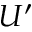<formula> <loc_0><loc_0><loc_500><loc_500>U ^ { \prime }</formula> 